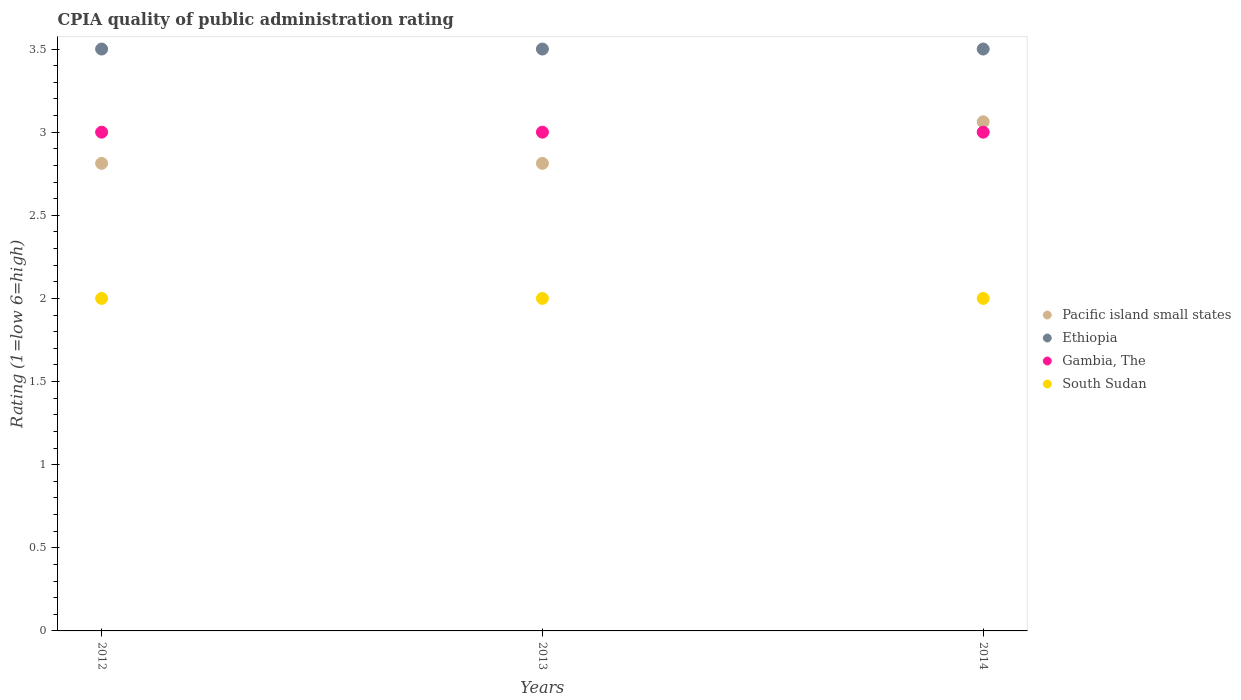Is the number of dotlines equal to the number of legend labels?
Ensure brevity in your answer.  Yes. What is the CPIA rating in Pacific island small states in 2012?
Offer a terse response. 2.81. In which year was the CPIA rating in Ethiopia maximum?
Make the answer very short. 2012. What is the total CPIA rating in Pacific island small states in the graph?
Give a very brief answer. 8.69. What is the average CPIA rating in Pacific island small states per year?
Provide a succinct answer. 2.9. In the year 2013, what is the difference between the CPIA rating in Pacific island small states and CPIA rating in Gambia, The?
Offer a terse response. -0.19. What is the ratio of the CPIA rating in South Sudan in 2012 to that in 2014?
Your response must be concise. 1. Is the CPIA rating in South Sudan in 2013 less than that in 2014?
Offer a very short reply. No. What is the difference between the highest and the lowest CPIA rating in South Sudan?
Provide a succinct answer. 0. Is the sum of the CPIA rating in South Sudan in 2013 and 2014 greater than the maximum CPIA rating in Pacific island small states across all years?
Offer a terse response. Yes. Is it the case that in every year, the sum of the CPIA rating in Gambia, The and CPIA rating in Ethiopia  is greater than the sum of CPIA rating in Pacific island small states and CPIA rating in South Sudan?
Keep it short and to the point. Yes. How many years are there in the graph?
Ensure brevity in your answer.  3. What is the difference between two consecutive major ticks on the Y-axis?
Keep it short and to the point. 0.5. Are the values on the major ticks of Y-axis written in scientific E-notation?
Your answer should be very brief. No. Does the graph contain any zero values?
Keep it short and to the point. No. Does the graph contain grids?
Provide a succinct answer. No. How many legend labels are there?
Provide a succinct answer. 4. How are the legend labels stacked?
Keep it short and to the point. Vertical. What is the title of the graph?
Provide a succinct answer. CPIA quality of public administration rating. Does "Indonesia" appear as one of the legend labels in the graph?
Your response must be concise. No. What is the Rating (1=low 6=high) in Pacific island small states in 2012?
Offer a very short reply. 2.81. What is the Rating (1=low 6=high) in Pacific island small states in 2013?
Give a very brief answer. 2.81. What is the Rating (1=low 6=high) in Pacific island small states in 2014?
Make the answer very short. 3.06. What is the Rating (1=low 6=high) of Gambia, The in 2014?
Offer a very short reply. 3. Across all years, what is the maximum Rating (1=low 6=high) in Pacific island small states?
Your answer should be very brief. 3.06. Across all years, what is the maximum Rating (1=low 6=high) in Ethiopia?
Keep it short and to the point. 3.5. Across all years, what is the minimum Rating (1=low 6=high) of Pacific island small states?
Your response must be concise. 2.81. What is the total Rating (1=low 6=high) of Pacific island small states in the graph?
Provide a succinct answer. 8.69. What is the total Rating (1=low 6=high) of Ethiopia in the graph?
Your answer should be very brief. 10.5. What is the total Rating (1=low 6=high) in Gambia, The in the graph?
Your answer should be compact. 9. What is the difference between the Rating (1=low 6=high) of Pacific island small states in 2012 and that in 2013?
Offer a very short reply. 0. What is the difference between the Rating (1=low 6=high) of Ethiopia in 2012 and that in 2013?
Your answer should be compact. 0. What is the difference between the Rating (1=low 6=high) in Gambia, The in 2012 and that in 2013?
Provide a short and direct response. 0. What is the difference between the Rating (1=low 6=high) of South Sudan in 2012 and that in 2013?
Ensure brevity in your answer.  0. What is the difference between the Rating (1=low 6=high) in Ethiopia in 2012 and that in 2014?
Your response must be concise. 0. What is the difference between the Rating (1=low 6=high) of South Sudan in 2013 and that in 2014?
Provide a succinct answer. 0. What is the difference between the Rating (1=low 6=high) in Pacific island small states in 2012 and the Rating (1=low 6=high) in Ethiopia in 2013?
Make the answer very short. -0.69. What is the difference between the Rating (1=low 6=high) in Pacific island small states in 2012 and the Rating (1=low 6=high) in Gambia, The in 2013?
Ensure brevity in your answer.  -0.19. What is the difference between the Rating (1=low 6=high) in Pacific island small states in 2012 and the Rating (1=low 6=high) in South Sudan in 2013?
Give a very brief answer. 0.81. What is the difference between the Rating (1=low 6=high) of Ethiopia in 2012 and the Rating (1=low 6=high) of South Sudan in 2013?
Offer a terse response. 1.5. What is the difference between the Rating (1=low 6=high) in Gambia, The in 2012 and the Rating (1=low 6=high) in South Sudan in 2013?
Make the answer very short. 1. What is the difference between the Rating (1=low 6=high) in Pacific island small states in 2012 and the Rating (1=low 6=high) in Ethiopia in 2014?
Give a very brief answer. -0.69. What is the difference between the Rating (1=low 6=high) in Pacific island small states in 2012 and the Rating (1=low 6=high) in Gambia, The in 2014?
Offer a terse response. -0.19. What is the difference between the Rating (1=low 6=high) in Pacific island small states in 2012 and the Rating (1=low 6=high) in South Sudan in 2014?
Your answer should be very brief. 0.81. What is the difference between the Rating (1=low 6=high) of Ethiopia in 2012 and the Rating (1=low 6=high) of Gambia, The in 2014?
Provide a succinct answer. 0.5. What is the difference between the Rating (1=low 6=high) in Pacific island small states in 2013 and the Rating (1=low 6=high) in Ethiopia in 2014?
Provide a short and direct response. -0.69. What is the difference between the Rating (1=low 6=high) in Pacific island small states in 2013 and the Rating (1=low 6=high) in Gambia, The in 2014?
Ensure brevity in your answer.  -0.19. What is the difference between the Rating (1=low 6=high) in Pacific island small states in 2013 and the Rating (1=low 6=high) in South Sudan in 2014?
Provide a short and direct response. 0.81. What is the difference between the Rating (1=low 6=high) of Gambia, The in 2013 and the Rating (1=low 6=high) of South Sudan in 2014?
Provide a succinct answer. 1. What is the average Rating (1=low 6=high) in Pacific island small states per year?
Your answer should be compact. 2.9. What is the average Rating (1=low 6=high) in Ethiopia per year?
Your answer should be very brief. 3.5. In the year 2012, what is the difference between the Rating (1=low 6=high) of Pacific island small states and Rating (1=low 6=high) of Ethiopia?
Provide a succinct answer. -0.69. In the year 2012, what is the difference between the Rating (1=low 6=high) of Pacific island small states and Rating (1=low 6=high) of Gambia, The?
Give a very brief answer. -0.19. In the year 2012, what is the difference between the Rating (1=low 6=high) of Pacific island small states and Rating (1=low 6=high) of South Sudan?
Keep it short and to the point. 0.81. In the year 2012, what is the difference between the Rating (1=low 6=high) of Gambia, The and Rating (1=low 6=high) of South Sudan?
Give a very brief answer. 1. In the year 2013, what is the difference between the Rating (1=low 6=high) of Pacific island small states and Rating (1=low 6=high) of Ethiopia?
Ensure brevity in your answer.  -0.69. In the year 2013, what is the difference between the Rating (1=low 6=high) in Pacific island small states and Rating (1=low 6=high) in Gambia, The?
Offer a very short reply. -0.19. In the year 2013, what is the difference between the Rating (1=low 6=high) in Pacific island small states and Rating (1=low 6=high) in South Sudan?
Provide a short and direct response. 0.81. In the year 2013, what is the difference between the Rating (1=low 6=high) of Ethiopia and Rating (1=low 6=high) of Gambia, The?
Make the answer very short. 0.5. In the year 2013, what is the difference between the Rating (1=low 6=high) of Ethiopia and Rating (1=low 6=high) of South Sudan?
Give a very brief answer. 1.5. In the year 2013, what is the difference between the Rating (1=low 6=high) in Gambia, The and Rating (1=low 6=high) in South Sudan?
Make the answer very short. 1. In the year 2014, what is the difference between the Rating (1=low 6=high) in Pacific island small states and Rating (1=low 6=high) in Ethiopia?
Give a very brief answer. -0.44. In the year 2014, what is the difference between the Rating (1=low 6=high) in Pacific island small states and Rating (1=low 6=high) in Gambia, The?
Your response must be concise. 0.06. In the year 2014, what is the difference between the Rating (1=low 6=high) of Ethiopia and Rating (1=low 6=high) of Gambia, The?
Ensure brevity in your answer.  0.5. In the year 2014, what is the difference between the Rating (1=low 6=high) in Ethiopia and Rating (1=low 6=high) in South Sudan?
Give a very brief answer. 1.5. What is the ratio of the Rating (1=low 6=high) in Pacific island small states in 2012 to that in 2013?
Provide a short and direct response. 1. What is the ratio of the Rating (1=low 6=high) of Ethiopia in 2012 to that in 2013?
Provide a short and direct response. 1. What is the ratio of the Rating (1=low 6=high) of Gambia, The in 2012 to that in 2013?
Offer a terse response. 1. What is the ratio of the Rating (1=low 6=high) of South Sudan in 2012 to that in 2013?
Offer a terse response. 1. What is the ratio of the Rating (1=low 6=high) of Pacific island small states in 2012 to that in 2014?
Offer a terse response. 0.92. What is the ratio of the Rating (1=low 6=high) of South Sudan in 2012 to that in 2014?
Your answer should be compact. 1. What is the ratio of the Rating (1=low 6=high) in Pacific island small states in 2013 to that in 2014?
Provide a short and direct response. 0.92. What is the difference between the highest and the second highest Rating (1=low 6=high) in Pacific island small states?
Provide a short and direct response. 0.25. What is the difference between the highest and the second highest Rating (1=low 6=high) of Ethiopia?
Make the answer very short. 0. What is the difference between the highest and the lowest Rating (1=low 6=high) of Pacific island small states?
Give a very brief answer. 0.25. What is the difference between the highest and the lowest Rating (1=low 6=high) of Ethiopia?
Ensure brevity in your answer.  0. What is the difference between the highest and the lowest Rating (1=low 6=high) in South Sudan?
Keep it short and to the point. 0. 